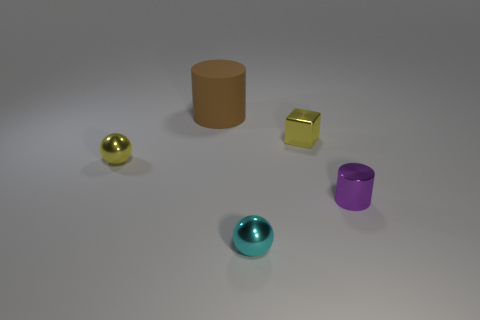Describe the colors of the objects and what they might imply about the materials. There are objects in yellow, purple, gold, and teal colors. The vividness and variety suggest the materials could be plastic, ceramic, or even painted metal. These colors could be used to differentiate objects for instructional purposes or simply for aesthetic display. 